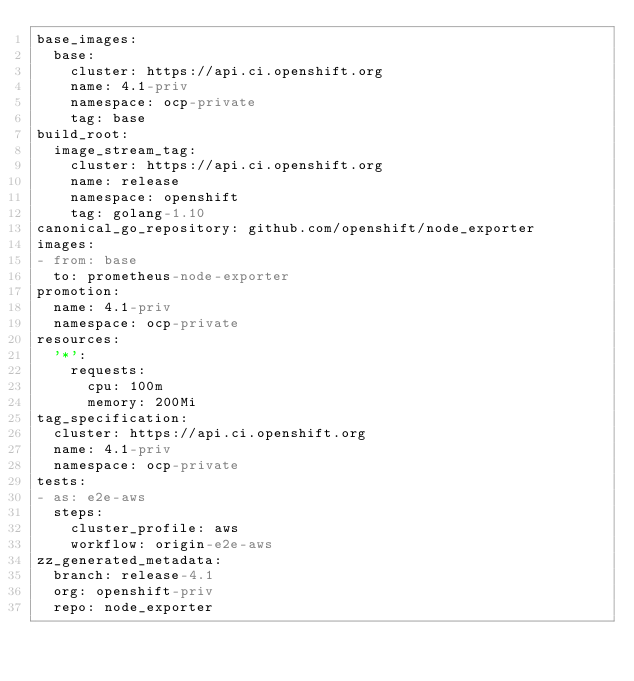<code> <loc_0><loc_0><loc_500><loc_500><_YAML_>base_images:
  base:
    cluster: https://api.ci.openshift.org
    name: 4.1-priv
    namespace: ocp-private
    tag: base
build_root:
  image_stream_tag:
    cluster: https://api.ci.openshift.org
    name: release
    namespace: openshift
    tag: golang-1.10
canonical_go_repository: github.com/openshift/node_exporter
images:
- from: base
  to: prometheus-node-exporter
promotion:
  name: 4.1-priv
  namespace: ocp-private
resources:
  '*':
    requests:
      cpu: 100m
      memory: 200Mi
tag_specification:
  cluster: https://api.ci.openshift.org
  name: 4.1-priv
  namespace: ocp-private
tests:
- as: e2e-aws
  steps:
    cluster_profile: aws
    workflow: origin-e2e-aws
zz_generated_metadata:
  branch: release-4.1
  org: openshift-priv
  repo: node_exporter
</code> 